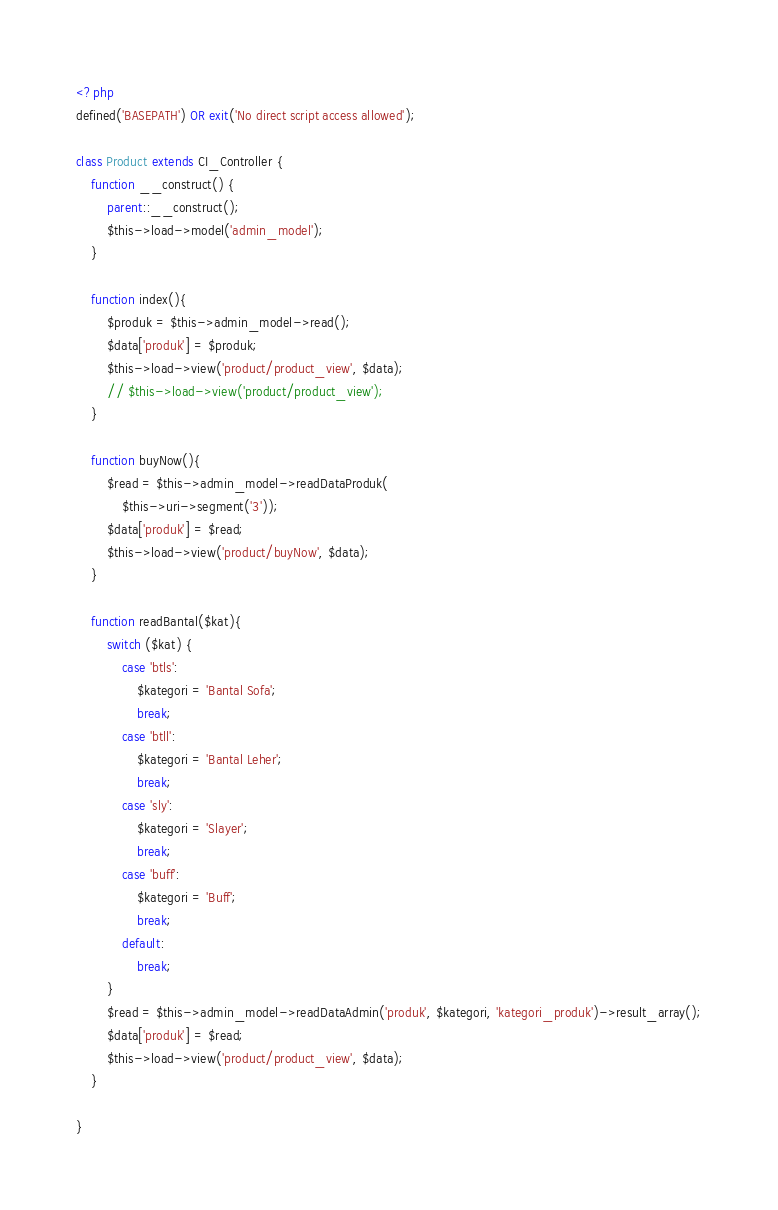<code> <loc_0><loc_0><loc_500><loc_500><_PHP_><?php
defined('BASEPATH') OR exit('No direct script access allowed');

class Product extends CI_Controller {
	function __construct() {
        parent::__construct();
        $this->load->model('admin_model');
    }

	function index(){
		$produk = $this->admin_model->read();
		$data['produk'] = $produk;
		$this->load->view('product/product_view', $data);
		// $this->load->view('product/product_view');
	}

	function buyNow(){
		$read = $this->admin_model->readDataProduk(
			$this->uri->segment('3'));
		$data['produk'] = $read;
		$this->load->view('product/buyNow', $data);
	}
	
	function readBantal($kat){
		switch ($kat) {
			case 'btls':
				$kategori = 'Bantal Sofa';
				break;
			case 'btll':
				$kategori = 'Bantal Leher';
				break;
			case 'sly':
				$kategori = 'Slayer';
				break;
			case 'buff':
				$kategori = 'Buff';
				break;
			default:
				break;
		}
		$read = $this->admin_model->readDataAdmin('produk', $kategori, 'kategori_produk')->result_array();
		$data['produk'] = $read;
		$this->load->view('product/product_view', $data);
	}

}</code> 